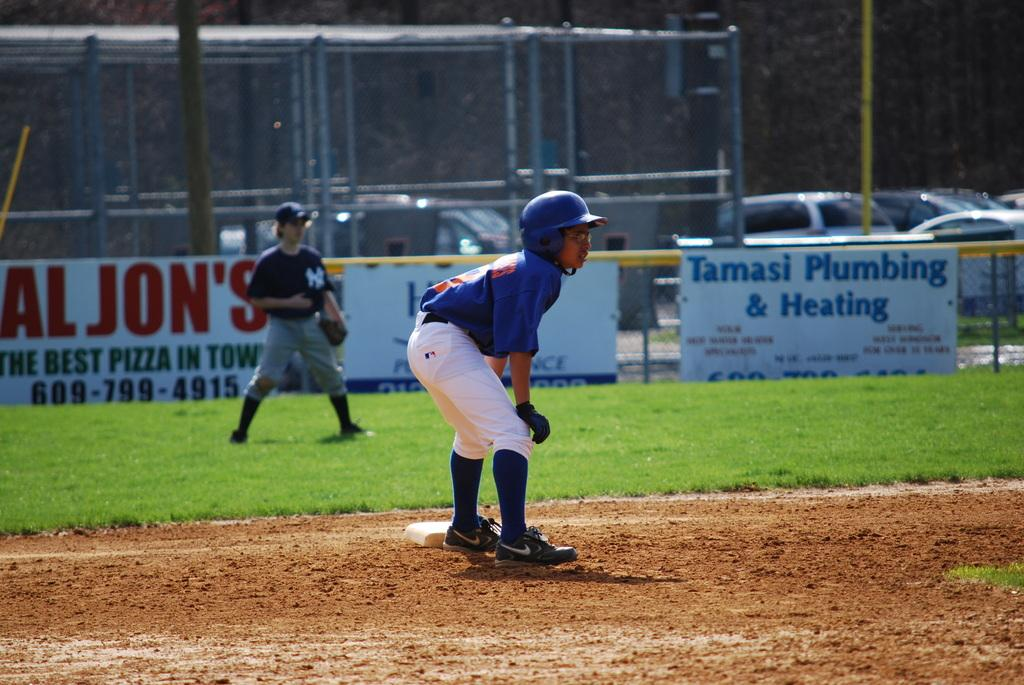<image>
Share a concise interpretation of the image provided. A baseball player stands on base in front of a Tamasi Plumbing & Heating sign. 